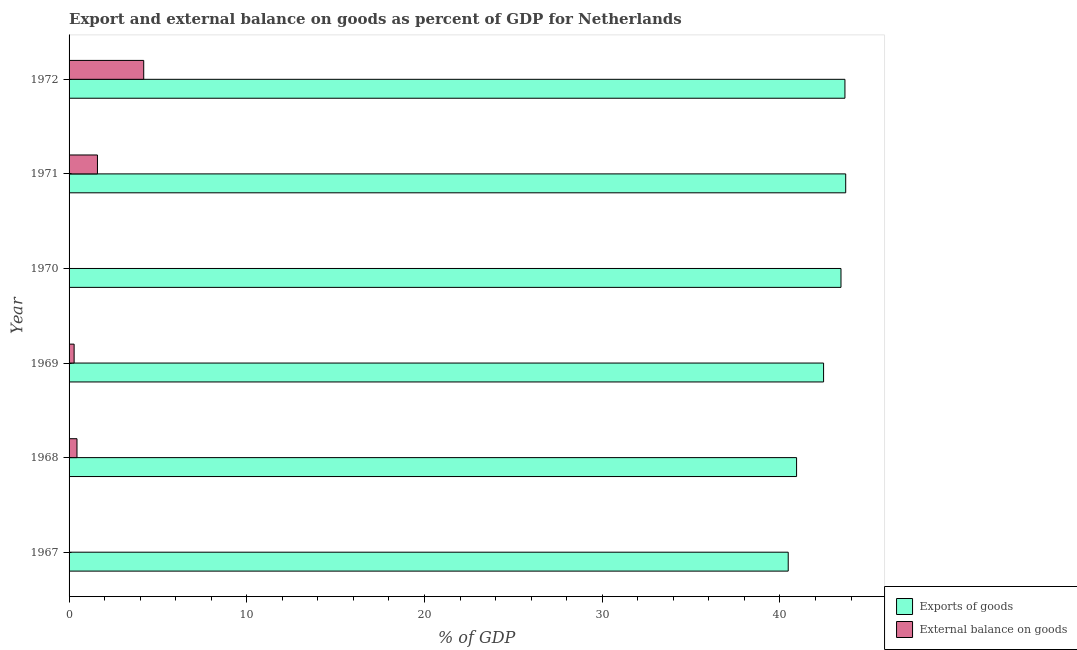How many different coloured bars are there?
Provide a short and direct response. 2. Are the number of bars per tick equal to the number of legend labels?
Offer a very short reply. No. Are the number of bars on each tick of the Y-axis equal?
Ensure brevity in your answer.  No. What is the label of the 1st group of bars from the top?
Keep it short and to the point. 1972. What is the external balance on goods as percentage of gdp in 1972?
Provide a succinct answer. 4.2. Across all years, what is the maximum export of goods as percentage of gdp?
Provide a succinct answer. 43.7. What is the total export of goods as percentage of gdp in the graph?
Offer a very short reply. 254.66. What is the difference between the external balance on goods as percentage of gdp in 1969 and that in 1971?
Provide a short and direct response. -1.31. What is the difference between the export of goods as percentage of gdp in 1969 and the external balance on goods as percentage of gdp in 1972?
Make the answer very short. 38.26. What is the average external balance on goods as percentage of gdp per year?
Keep it short and to the point. 1.09. In the year 1972, what is the difference between the export of goods as percentage of gdp and external balance on goods as percentage of gdp?
Provide a succinct answer. 39.46. What is the ratio of the export of goods as percentage of gdp in 1968 to that in 1972?
Give a very brief answer. 0.94. What is the difference between the highest and the second highest external balance on goods as percentage of gdp?
Ensure brevity in your answer.  2.6. Is the sum of the export of goods as percentage of gdp in 1969 and 1970 greater than the maximum external balance on goods as percentage of gdp across all years?
Provide a succinct answer. Yes. Are all the bars in the graph horizontal?
Your answer should be compact. Yes. How many years are there in the graph?
Keep it short and to the point. 6. Are the values on the major ticks of X-axis written in scientific E-notation?
Your response must be concise. No. Where does the legend appear in the graph?
Provide a short and direct response. Bottom right. What is the title of the graph?
Provide a short and direct response. Export and external balance on goods as percent of GDP for Netherlands. What is the label or title of the X-axis?
Make the answer very short. % of GDP. What is the label or title of the Y-axis?
Provide a succinct answer. Year. What is the % of GDP in Exports of goods in 1967?
Keep it short and to the point. 40.47. What is the % of GDP of External balance on goods in 1967?
Ensure brevity in your answer.  0. What is the % of GDP in Exports of goods in 1968?
Your answer should be compact. 40.94. What is the % of GDP of External balance on goods in 1968?
Make the answer very short. 0.45. What is the % of GDP in Exports of goods in 1969?
Make the answer very short. 42.46. What is the % of GDP of External balance on goods in 1969?
Your answer should be very brief. 0.28. What is the % of GDP in Exports of goods in 1970?
Your response must be concise. 43.44. What is the % of GDP of External balance on goods in 1970?
Give a very brief answer. 0. What is the % of GDP of Exports of goods in 1971?
Your answer should be very brief. 43.7. What is the % of GDP of External balance on goods in 1971?
Your answer should be very brief. 1.6. What is the % of GDP of Exports of goods in 1972?
Keep it short and to the point. 43.66. What is the % of GDP in External balance on goods in 1972?
Provide a succinct answer. 4.2. Across all years, what is the maximum % of GDP of Exports of goods?
Your answer should be compact. 43.7. Across all years, what is the maximum % of GDP of External balance on goods?
Keep it short and to the point. 4.2. Across all years, what is the minimum % of GDP of Exports of goods?
Provide a succinct answer. 40.47. What is the total % of GDP in Exports of goods in the graph?
Your answer should be very brief. 254.66. What is the total % of GDP in External balance on goods in the graph?
Your response must be concise. 6.53. What is the difference between the % of GDP in Exports of goods in 1967 and that in 1968?
Give a very brief answer. -0.47. What is the difference between the % of GDP in Exports of goods in 1967 and that in 1969?
Offer a very short reply. -1.99. What is the difference between the % of GDP of Exports of goods in 1967 and that in 1970?
Provide a short and direct response. -2.97. What is the difference between the % of GDP of Exports of goods in 1967 and that in 1971?
Your response must be concise. -3.23. What is the difference between the % of GDP in Exports of goods in 1967 and that in 1972?
Your answer should be compact. -3.19. What is the difference between the % of GDP of Exports of goods in 1968 and that in 1969?
Ensure brevity in your answer.  -1.52. What is the difference between the % of GDP of External balance on goods in 1968 and that in 1969?
Make the answer very short. 0.16. What is the difference between the % of GDP of Exports of goods in 1968 and that in 1970?
Offer a terse response. -2.5. What is the difference between the % of GDP of Exports of goods in 1968 and that in 1971?
Your response must be concise. -2.76. What is the difference between the % of GDP of External balance on goods in 1968 and that in 1971?
Provide a short and direct response. -1.15. What is the difference between the % of GDP of Exports of goods in 1968 and that in 1972?
Make the answer very short. -2.72. What is the difference between the % of GDP in External balance on goods in 1968 and that in 1972?
Provide a succinct answer. -3.76. What is the difference between the % of GDP of Exports of goods in 1969 and that in 1970?
Your answer should be very brief. -0.98. What is the difference between the % of GDP of Exports of goods in 1969 and that in 1971?
Make the answer very short. -1.25. What is the difference between the % of GDP in External balance on goods in 1969 and that in 1971?
Provide a short and direct response. -1.31. What is the difference between the % of GDP of Exports of goods in 1969 and that in 1972?
Offer a terse response. -1.2. What is the difference between the % of GDP of External balance on goods in 1969 and that in 1972?
Give a very brief answer. -3.92. What is the difference between the % of GDP of Exports of goods in 1970 and that in 1971?
Keep it short and to the point. -0.27. What is the difference between the % of GDP of Exports of goods in 1970 and that in 1972?
Offer a very short reply. -0.22. What is the difference between the % of GDP of Exports of goods in 1971 and that in 1972?
Offer a terse response. 0.04. What is the difference between the % of GDP in External balance on goods in 1971 and that in 1972?
Your answer should be compact. -2.6. What is the difference between the % of GDP of Exports of goods in 1967 and the % of GDP of External balance on goods in 1968?
Give a very brief answer. 40.02. What is the difference between the % of GDP of Exports of goods in 1967 and the % of GDP of External balance on goods in 1969?
Provide a succinct answer. 40.18. What is the difference between the % of GDP of Exports of goods in 1967 and the % of GDP of External balance on goods in 1971?
Your answer should be very brief. 38.87. What is the difference between the % of GDP of Exports of goods in 1967 and the % of GDP of External balance on goods in 1972?
Ensure brevity in your answer.  36.27. What is the difference between the % of GDP in Exports of goods in 1968 and the % of GDP in External balance on goods in 1969?
Offer a very short reply. 40.65. What is the difference between the % of GDP in Exports of goods in 1968 and the % of GDP in External balance on goods in 1971?
Keep it short and to the point. 39.34. What is the difference between the % of GDP in Exports of goods in 1968 and the % of GDP in External balance on goods in 1972?
Your response must be concise. 36.74. What is the difference between the % of GDP of Exports of goods in 1969 and the % of GDP of External balance on goods in 1971?
Ensure brevity in your answer.  40.86. What is the difference between the % of GDP of Exports of goods in 1969 and the % of GDP of External balance on goods in 1972?
Provide a succinct answer. 38.26. What is the difference between the % of GDP of Exports of goods in 1970 and the % of GDP of External balance on goods in 1971?
Keep it short and to the point. 41.84. What is the difference between the % of GDP in Exports of goods in 1970 and the % of GDP in External balance on goods in 1972?
Your response must be concise. 39.24. What is the difference between the % of GDP in Exports of goods in 1971 and the % of GDP in External balance on goods in 1972?
Your answer should be very brief. 39.5. What is the average % of GDP in Exports of goods per year?
Your answer should be compact. 42.44. What is the average % of GDP of External balance on goods per year?
Your answer should be compact. 1.09. In the year 1968, what is the difference between the % of GDP in Exports of goods and % of GDP in External balance on goods?
Offer a terse response. 40.49. In the year 1969, what is the difference between the % of GDP in Exports of goods and % of GDP in External balance on goods?
Provide a short and direct response. 42.17. In the year 1971, what is the difference between the % of GDP in Exports of goods and % of GDP in External balance on goods?
Your response must be concise. 42.11. In the year 1972, what is the difference between the % of GDP of Exports of goods and % of GDP of External balance on goods?
Ensure brevity in your answer.  39.46. What is the ratio of the % of GDP of Exports of goods in 1967 to that in 1969?
Offer a terse response. 0.95. What is the ratio of the % of GDP in Exports of goods in 1967 to that in 1970?
Keep it short and to the point. 0.93. What is the ratio of the % of GDP in Exports of goods in 1967 to that in 1971?
Your answer should be compact. 0.93. What is the ratio of the % of GDP of Exports of goods in 1967 to that in 1972?
Your answer should be compact. 0.93. What is the ratio of the % of GDP of Exports of goods in 1968 to that in 1969?
Your answer should be compact. 0.96. What is the ratio of the % of GDP in External balance on goods in 1968 to that in 1969?
Give a very brief answer. 1.56. What is the ratio of the % of GDP of Exports of goods in 1968 to that in 1970?
Your answer should be very brief. 0.94. What is the ratio of the % of GDP in Exports of goods in 1968 to that in 1971?
Give a very brief answer. 0.94. What is the ratio of the % of GDP of External balance on goods in 1968 to that in 1971?
Your answer should be very brief. 0.28. What is the ratio of the % of GDP in Exports of goods in 1968 to that in 1972?
Your answer should be compact. 0.94. What is the ratio of the % of GDP in External balance on goods in 1968 to that in 1972?
Your answer should be very brief. 0.11. What is the ratio of the % of GDP in Exports of goods in 1969 to that in 1970?
Ensure brevity in your answer.  0.98. What is the ratio of the % of GDP in Exports of goods in 1969 to that in 1971?
Provide a succinct answer. 0.97. What is the ratio of the % of GDP in External balance on goods in 1969 to that in 1971?
Make the answer very short. 0.18. What is the ratio of the % of GDP in Exports of goods in 1969 to that in 1972?
Offer a very short reply. 0.97. What is the ratio of the % of GDP of External balance on goods in 1969 to that in 1972?
Ensure brevity in your answer.  0.07. What is the ratio of the % of GDP in Exports of goods in 1970 to that in 1972?
Keep it short and to the point. 0.99. What is the ratio of the % of GDP of Exports of goods in 1971 to that in 1972?
Make the answer very short. 1. What is the ratio of the % of GDP in External balance on goods in 1971 to that in 1972?
Your answer should be very brief. 0.38. What is the difference between the highest and the second highest % of GDP in Exports of goods?
Offer a terse response. 0.04. What is the difference between the highest and the second highest % of GDP in External balance on goods?
Give a very brief answer. 2.6. What is the difference between the highest and the lowest % of GDP of Exports of goods?
Give a very brief answer. 3.23. What is the difference between the highest and the lowest % of GDP in External balance on goods?
Keep it short and to the point. 4.2. 